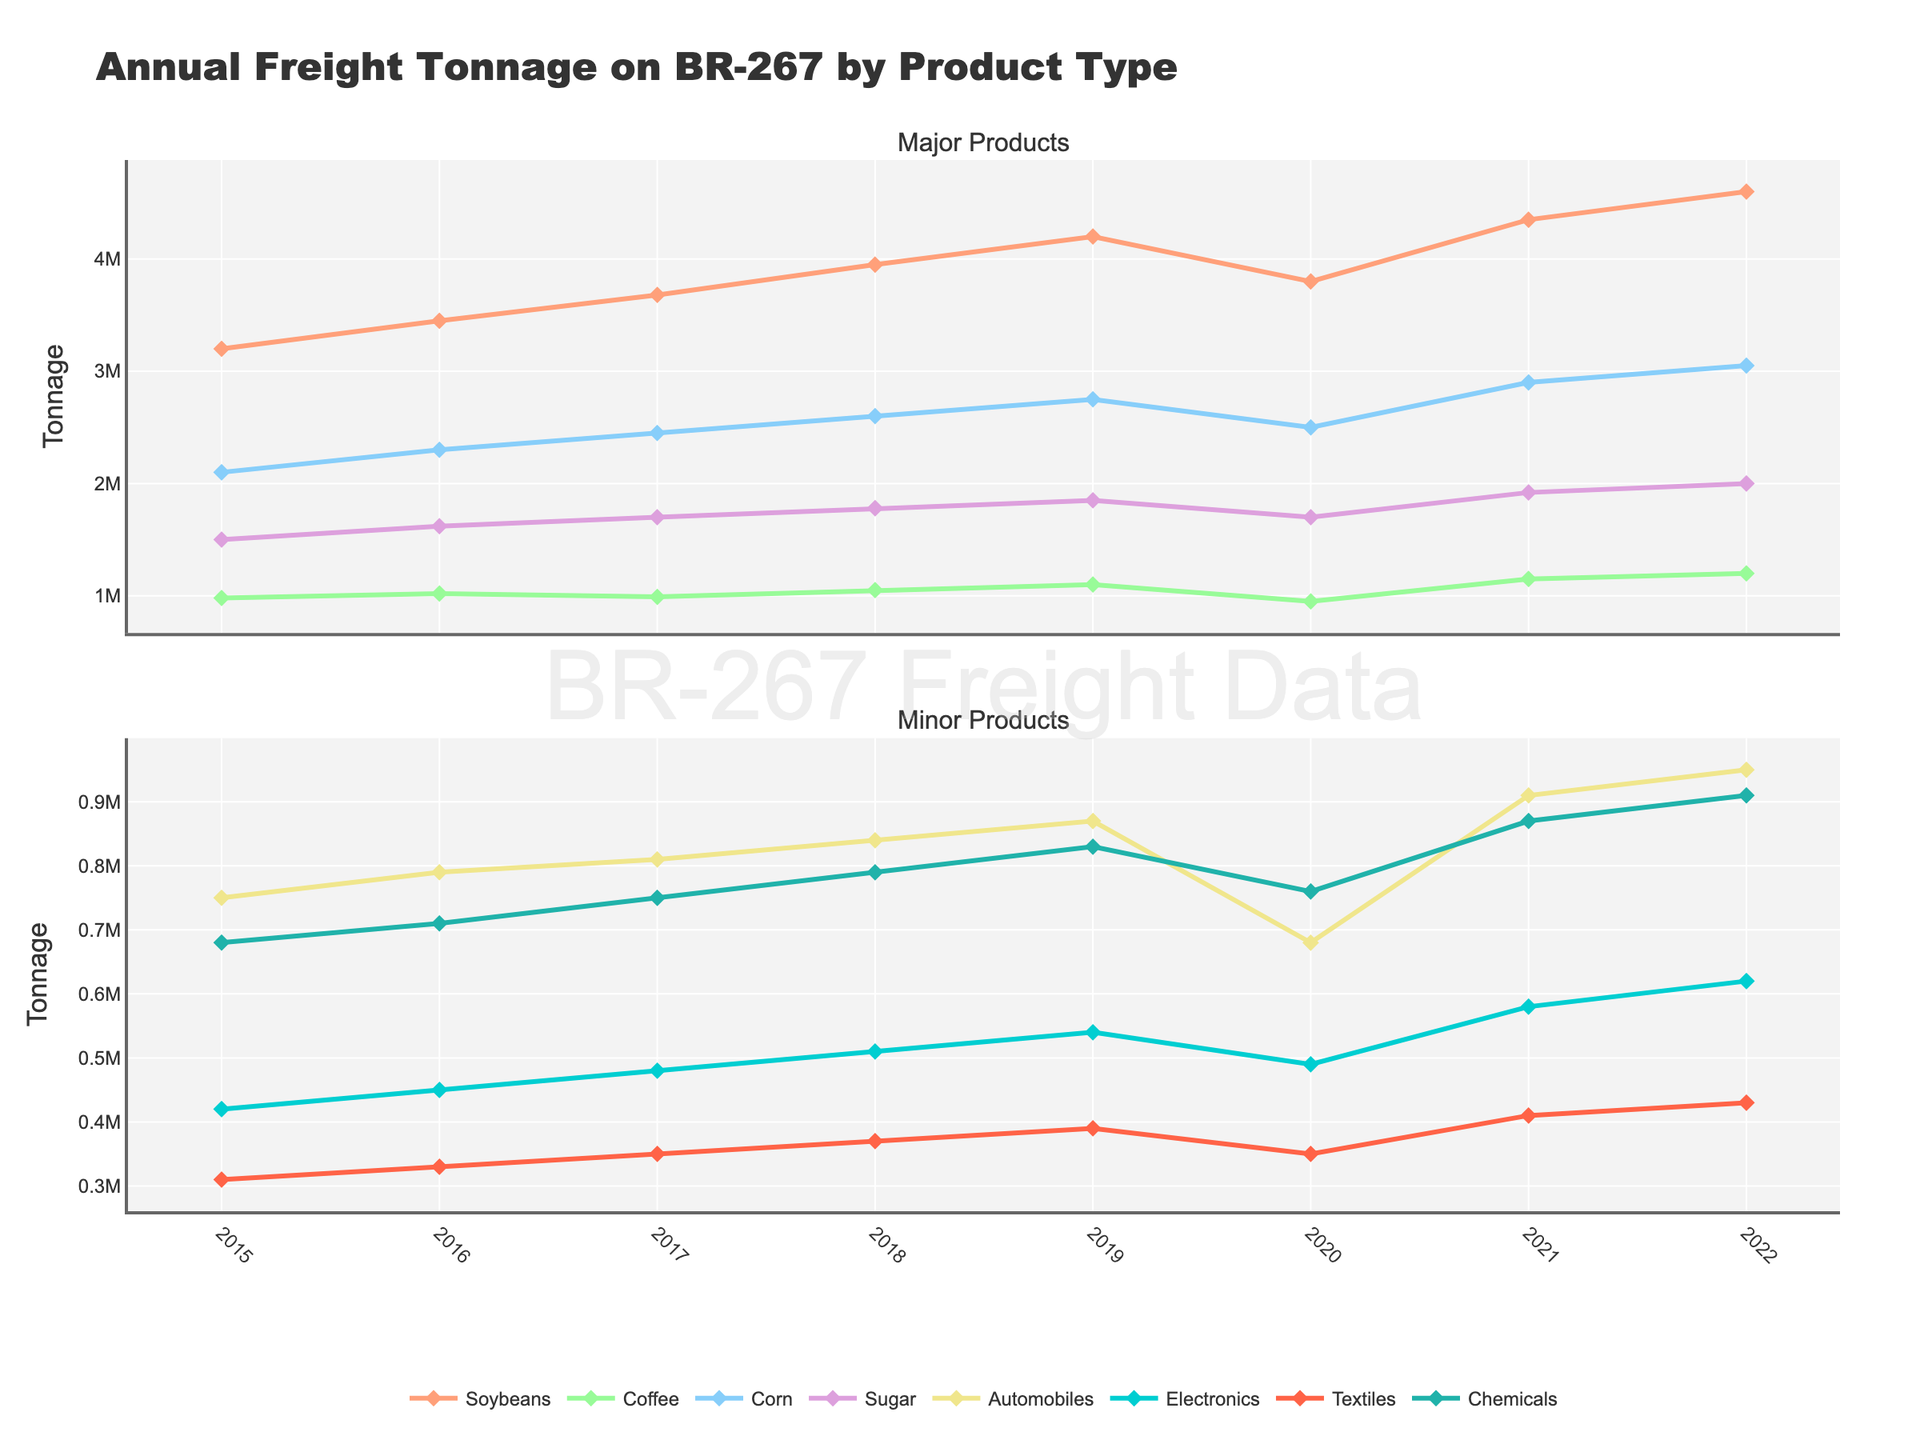What product experienced the largest increase in tonnage from 2015 to 2020? The largest increase is determined by comparing the 2015 and 2020 tonnage values for each product and finding the one with the greatest difference. Soybeans had an increase from 3,200,000 to 3,800,000 tons, which is an increase of 600,000 tons.
Answer: Soybeans In which year did Automobiles have their lowest tonnage transported and what was the tonnage? By examining the tonnage values for Automobiles over the years, the lowest value occurs in 2020 with 680,000 tons.
Answer: 2020, 680,000 What is the average annual tonnage of Textiles transported from 2015 to 2022? To find the average annual tonnage, sum the Textiles values for each year and divide by the number of years. The sum is 2,940,000, and dividing by 8 gives an average of 367,500 tons.
Answer: 367,500 Between Coffee and Corn, which product had a higher tonnage in 2017? By comparing the tonnage values in 2017, Coffee had 990,000 tons, while Corn had 2,450,000 tons. Corn had a higher tonnage.
Answer: Corn How did the tonnage for Chemicals change from 2019 to 2021? The tonnage for Chemicals went from 830,000 tons in 2019 to 870,000 tons in 2021, an increase of 40,000 tons.
Answer: Increased by 40,000 tons Which product had the smallest increase in tonnage from 2016 to 2017? By subtracting the 2016 values from the 2017 values for each product, Coffee had the smallest increase from 1,020,000 to 990,000 tons, which is a decrease of 30,000 tons.
Answer: Coffee What is the sum of tonnage for Soybeans and Sugar in 2022? By adding the 2022 values for Soybeans (4,600,000 tons) and Sugar (2,000,000 tons), the total is 6,600,000 tons.
Answer: 6,600,000 Which product had its peak tonnage in the year 2022? Analyzing each product's tonnage, we see that all listed products had their highest recorded tonnage in 2022.
Answer: All products What are the two primary colors used to represent the product with the highest average annual tonnage in the figure? The product with the highest average annual tonnage is Soybeans, colored in a shading of red.
Answer: Red How does the tonnage transported for Electronics in 2021 compare to the tonnage for Corn in 2020? In 2021, Electronics had a tonnage of 580,000, while Corn in 2020 had 2,500,000 tons, making Corn's tonnage significantly higher.
Answer: Corn's tonnage is significantly higher 